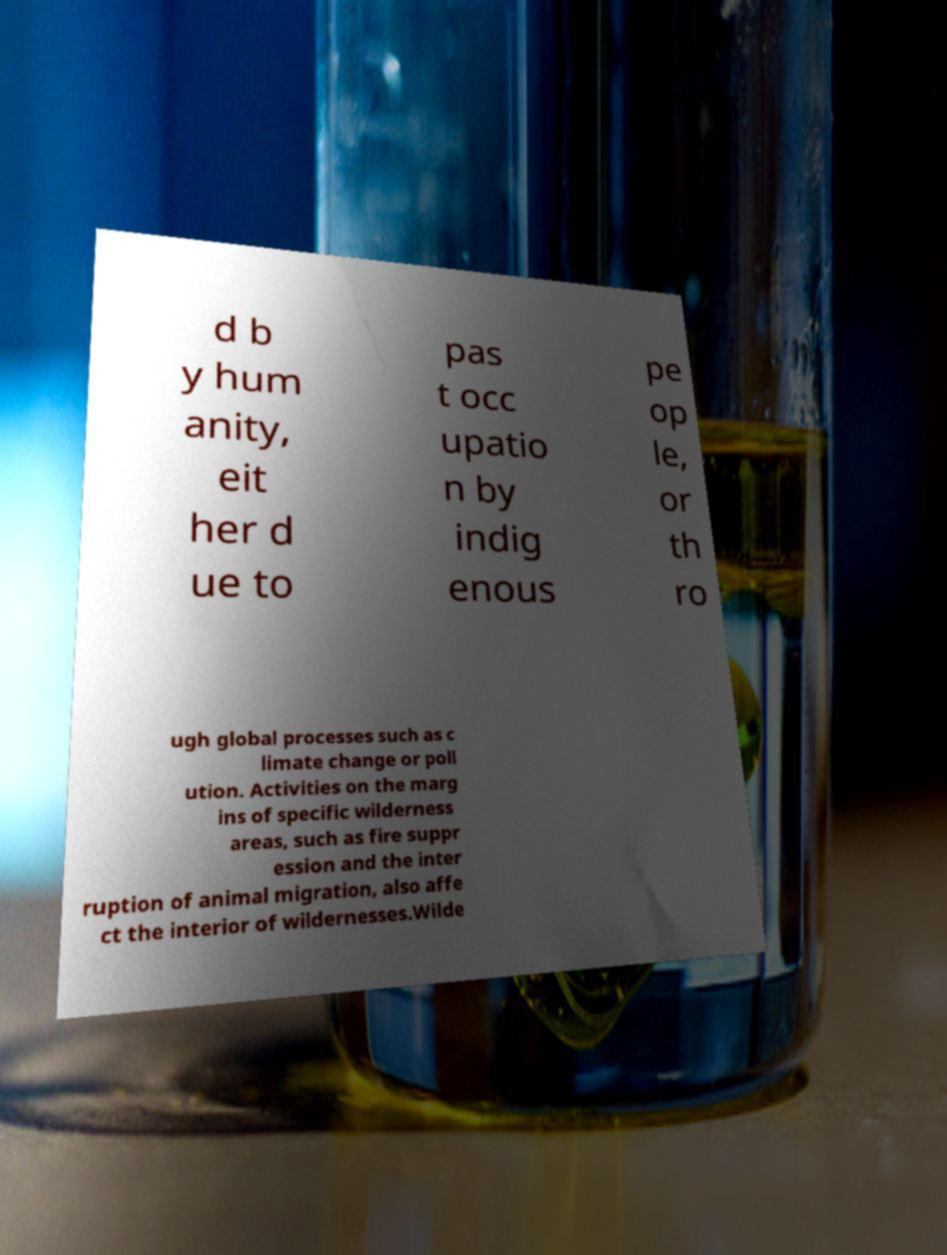Could you assist in decoding the text presented in this image and type it out clearly? d b y hum anity, eit her d ue to pas t occ upatio n by indig enous pe op le, or th ro ugh global processes such as c limate change or poll ution. Activities on the marg ins of specific wilderness areas, such as fire suppr ession and the inter ruption of animal migration, also affe ct the interior of wildernesses.Wilde 